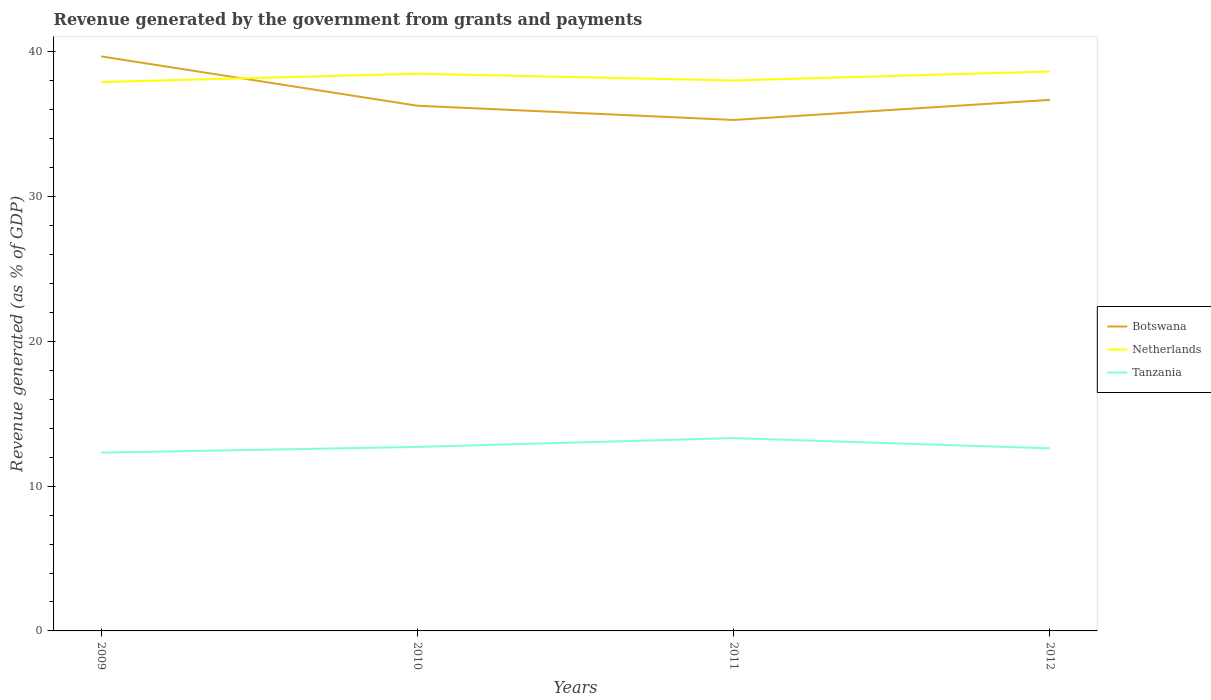Across all years, what is the maximum revenue generated by the government in Tanzania?
Your answer should be very brief. 12.31. What is the total revenue generated by the government in Tanzania in the graph?
Your answer should be compact. 0.71. What is the difference between the highest and the second highest revenue generated by the government in Botswana?
Provide a short and direct response. 4.39. What is the difference between the highest and the lowest revenue generated by the government in Botswana?
Provide a succinct answer. 1. Is the revenue generated by the government in Netherlands strictly greater than the revenue generated by the government in Tanzania over the years?
Offer a terse response. No. How many years are there in the graph?
Provide a succinct answer. 4. What is the difference between two consecutive major ticks on the Y-axis?
Provide a short and direct response. 10. Are the values on the major ticks of Y-axis written in scientific E-notation?
Offer a terse response. No. Does the graph contain any zero values?
Make the answer very short. No. How many legend labels are there?
Your answer should be very brief. 3. What is the title of the graph?
Keep it short and to the point. Revenue generated by the government from grants and payments. What is the label or title of the Y-axis?
Offer a terse response. Revenue generated (as % of GDP). What is the Revenue generated (as % of GDP) of Botswana in 2009?
Your answer should be very brief. 39.68. What is the Revenue generated (as % of GDP) in Netherlands in 2009?
Make the answer very short. 37.91. What is the Revenue generated (as % of GDP) of Tanzania in 2009?
Provide a short and direct response. 12.31. What is the Revenue generated (as % of GDP) in Botswana in 2010?
Your answer should be very brief. 36.27. What is the Revenue generated (as % of GDP) of Netherlands in 2010?
Give a very brief answer. 38.48. What is the Revenue generated (as % of GDP) of Tanzania in 2010?
Offer a very short reply. 12.71. What is the Revenue generated (as % of GDP) in Botswana in 2011?
Give a very brief answer. 35.29. What is the Revenue generated (as % of GDP) of Netherlands in 2011?
Your answer should be compact. 38.02. What is the Revenue generated (as % of GDP) in Tanzania in 2011?
Keep it short and to the point. 13.32. What is the Revenue generated (as % of GDP) of Botswana in 2012?
Your response must be concise. 36.68. What is the Revenue generated (as % of GDP) of Netherlands in 2012?
Your response must be concise. 38.64. What is the Revenue generated (as % of GDP) of Tanzania in 2012?
Offer a terse response. 12.61. Across all years, what is the maximum Revenue generated (as % of GDP) of Botswana?
Provide a succinct answer. 39.68. Across all years, what is the maximum Revenue generated (as % of GDP) of Netherlands?
Your answer should be very brief. 38.64. Across all years, what is the maximum Revenue generated (as % of GDP) of Tanzania?
Your answer should be compact. 13.32. Across all years, what is the minimum Revenue generated (as % of GDP) in Botswana?
Provide a succinct answer. 35.29. Across all years, what is the minimum Revenue generated (as % of GDP) of Netherlands?
Provide a succinct answer. 37.91. Across all years, what is the minimum Revenue generated (as % of GDP) in Tanzania?
Make the answer very short. 12.31. What is the total Revenue generated (as % of GDP) of Botswana in the graph?
Provide a succinct answer. 147.92. What is the total Revenue generated (as % of GDP) of Netherlands in the graph?
Your answer should be compact. 153.05. What is the total Revenue generated (as % of GDP) of Tanzania in the graph?
Your answer should be compact. 50.94. What is the difference between the Revenue generated (as % of GDP) in Botswana in 2009 and that in 2010?
Provide a succinct answer. 3.41. What is the difference between the Revenue generated (as % of GDP) of Netherlands in 2009 and that in 2010?
Your response must be concise. -0.58. What is the difference between the Revenue generated (as % of GDP) in Tanzania in 2009 and that in 2010?
Keep it short and to the point. -0.39. What is the difference between the Revenue generated (as % of GDP) in Botswana in 2009 and that in 2011?
Offer a very short reply. 4.39. What is the difference between the Revenue generated (as % of GDP) of Netherlands in 2009 and that in 2011?
Your answer should be compact. -0.11. What is the difference between the Revenue generated (as % of GDP) in Tanzania in 2009 and that in 2011?
Offer a terse response. -1. What is the difference between the Revenue generated (as % of GDP) of Botswana in 2009 and that in 2012?
Keep it short and to the point. 3. What is the difference between the Revenue generated (as % of GDP) of Netherlands in 2009 and that in 2012?
Your answer should be very brief. -0.73. What is the difference between the Revenue generated (as % of GDP) of Tanzania in 2009 and that in 2012?
Your response must be concise. -0.3. What is the difference between the Revenue generated (as % of GDP) in Botswana in 2010 and that in 2011?
Offer a very short reply. 0.98. What is the difference between the Revenue generated (as % of GDP) in Netherlands in 2010 and that in 2011?
Keep it short and to the point. 0.47. What is the difference between the Revenue generated (as % of GDP) in Tanzania in 2010 and that in 2011?
Keep it short and to the point. -0.61. What is the difference between the Revenue generated (as % of GDP) in Botswana in 2010 and that in 2012?
Ensure brevity in your answer.  -0.41. What is the difference between the Revenue generated (as % of GDP) of Netherlands in 2010 and that in 2012?
Offer a terse response. -0.16. What is the difference between the Revenue generated (as % of GDP) of Tanzania in 2010 and that in 2012?
Offer a very short reply. 0.1. What is the difference between the Revenue generated (as % of GDP) in Botswana in 2011 and that in 2012?
Provide a short and direct response. -1.39. What is the difference between the Revenue generated (as % of GDP) in Netherlands in 2011 and that in 2012?
Keep it short and to the point. -0.62. What is the difference between the Revenue generated (as % of GDP) of Tanzania in 2011 and that in 2012?
Provide a short and direct response. 0.71. What is the difference between the Revenue generated (as % of GDP) of Botswana in 2009 and the Revenue generated (as % of GDP) of Netherlands in 2010?
Make the answer very short. 1.2. What is the difference between the Revenue generated (as % of GDP) in Botswana in 2009 and the Revenue generated (as % of GDP) in Tanzania in 2010?
Make the answer very short. 26.97. What is the difference between the Revenue generated (as % of GDP) of Netherlands in 2009 and the Revenue generated (as % of GDP) of Tanzania in 2010?
Keep it short and to the point. 25.2. What is the difference between the Revenue generated (as % of GDP) in Botswana in 2009 and the Revenue generated (as % of GDP) in Netherlands in 2011?
Provide a succinct answer. 1.66. What is the difference between the Revenue generated (as % of GDP) of Botswana in 2009 and the Revenue generated (as % of GDP) of Tanzania in 2011?
Ensure brevity in your answer.  26.36. What is the difference between the Revenue generated (as % of GDP) in Netherlands in 2009 and the Revenue generated (as % of GDP) in Tanzania in 2011?
Your response must be concise. 24.59. What is the difference between the Revenue generated (as % of GDP) in Botswana in 2009 and the Revenue generated (as % of GDP) in Netherlands in 2012?
Offer a very short reply. 1.04. What is the difference between the Revenue generated (as % of GDP) of Botswana in 2009 and the Revenue generated (as % of GDP) of Tanzania in 2012?
Your answer should be compact. 27.07. What is the difference between the Revenue generated (as % of GDP) of Netherlands in 2009 and the Revenue generated (as % of GDP) of Tanzania in 2012?
Offer a terse response. 25.3. What is the difference between the Revenue generated (as % of GDP) in Botswana in 2010 and the Revenue generated (as % of GDP) in Netherlands in 2011?
Your answer should be compact. -1.74. What is the difference between the Revenue generated (as % of GDP) in Botswana in 2010 and the Revenue generated (as % of GDP) in Tanzania in 2011?
Keep it short and to the point. 22.96. What is the difference between the Revenue generated (as % of GDP) in Netherlands in 2010 and the Revenue generated (as % of GDP) in Tanzania in 2011?
Your answer should be compact. 25.17. What is the difference between the Revenue generated (as % of GDP) of Botswana in 2010 and the Revenue generated (as % of GDP) of Netherlands in 2012?
Your answer should be very brief. -2.37. What is the difference between the Revenue generated (as % of GDP) in Botswana in 2010 and the Revenue generated (as % of GDP) in Tanzania in 2012?
Ensure brevity in your answer.  23.66. What is the difference between the Revenue generated (as % of GDP) of Netherlands in 2010 and the Revenue generated (as % of GDP) of Tanzania in 2012?
Keep it short and to the point. 25.88. What is the difference between the Revenue generated (as % of GDP) in Botswana in 2011 and the Revenue generated (as % of GDP) in Netherlands in 2012?
Offer a terse response. -3.35. What is the difference between the Revenue generated (as % of GDP) in Botswana in 2011 and the Revenue generated (as % of GDP) in Tanzania in 2012?
Your answer should be very brief. 22.68. What is the difference between the Revenue generated (as % of GDP) of Netherlands in 2011 and the Revenue generated (as % of GDP) of Tanzania in 2012?
Offer a very short reply. 25.41. What is the average Revenue generated (as % of GDP) in Botswana per year?
Give a very brief answer. 36.98. What is the average Revenue generated (as % of GDP) of Netherlands per year?
Ensure brevity in your answer.  38.26. What is the average Revenue generated (as % of GDP) in Tanzania per year?
Your response must be concise. 12.74. In the year 2009, what is the difference between the Revenue generated (as % of GDP) of Botswana and Revenue generated (as % of GDP) of Netherlands?
Give a very brief answer. 1.77. In the year 2009, what is the difference between the Revenue generated (as % of GDP) in Botswana and Revenue generated (as % of GDP) in Tanzania?
Make the answer very short. 27.37. In the year 2009, what is the difference between the Revenue generated (as % of GDP) of Netherlands and Revenue generated (as % of GDP) of Tanzania?
Your answer should be very brief. 25.6. In the year 2010, what is the difference between the Revenue generated (as % of GDP) of Botswana and Revenue generated (as % of GDP) of Netherlands?
Your answer should be very brief. -2.21. In the year 2010, what is the difference between the Revenue generated (as % of GDP) of Botswana and Revenue generated (as % of GDP) of Tanzania?
Offer a terse response. 23.57. In the year 2010, what is the difference between the Revenue generated (as % of GDP) in Netherlands and Revenue generated (as % of GDP) in Tanzania?
Your answer should be compact. 25.78. In the year 2011, what is the difference between the Revenue generated (as % of GDP) of Botswana and Revenue generated (as % of GDP) of Netherlands?
Your response must be concise. -2.73. In the year 2011, what is the difference between the Revenue generated (as % of GDP) in Botswana and Revenue generated (as % of GDP) in Tanzania?
Provide a succinct answer. 21.97. In the year 2011, what is the difference between the Revenue generated (as % of GDP) in Netherlands and Revenue generated (as % of GDP) in Tanzania?
Ensure brevity in your answer.  24.7. In the year 2012, what is the difference between the Revenue generated (as % of GDP) in Botswana and Revenue generated (as % of GDP) in Netherlands?
Your answer should be compact. -1.96. In the year 2012, what is the difference between the Revenue generated (as % of GDP) of Botswana and Revenue generated (as % of GDP) of Tanzania?
Your answer should be compact. 24.07. In the year 2012, what is the difference between the Revenue generated (as % of GDP) of Netherlands and Revenue generated (as % of GDP) of Tanzania?
Provide a succinct answer. 26.03. What is the ratio of the Revenue generated (as % of GDP) in Botswana in 2009 to that in 2010?
Your answer should be compact. 1.09. What is the ratio of the Revenue generated (as % of GDP) of Netherlands in 2009 to that in 2010?
Provide a short and direct response. 0.98. What is the ratio of the Revenue generated (as % of GDP) in Tanzania in 2009 to that in 2010?
Give a very brief answer. 0.97. What is the ratio of the Revenue generated (as % of GDP) of Botswana in 2009 to that in 2011?
Make the answer very short. 1.12. What is the ratio of the Revenue generated (as % of GDP) of Netherlands in 2009 to that in 2011?
Keep it short and to the point. 1. What is the ratio of the Revenue generated (as % of GDP) in Tanzania in 2009 to that in 2011?
Keep it short and to the point. 0.92. What is the ratio of the Revenue generated (as % of GDP) of Botswana in 2009 to that in 2012?
Make the answer very short. 1.08. What is the ratio of the Revenue generated (as % of GDP) of Netherlands in 2009 to that in 2012?
Offer a very short reply. 0.98. What is the ratio of the Revenue generated (as % of GDP) in Tanzania in 2009 to that in 2012?
Provide a succinct answer. 0.98. What is the ratio of the Revenue generated (as % of GDP) of Botswana in 2010 to that in 2011?
Your response must be concise. 1.03. What is the ratio of the Revenue generated (as % of GDP) in Netherlands in 2010 to that in 2011?
Offer a very short reply. 1.01. What is the ratio of the Revenue generated (as % of GDP) in Tanzania in 2010 to that in 2011?
Your answer should be compact. 0.95. What is the ratio of the Revenue generated (as % of GDP) in Botswana in 2010 to that in 2012?
Make the answer very short. 0.99. What is the ratio of the Revenue generated (as % of GDP) in Netherlands in 2010 to that in 2012?
Your answer should be very brief. 1. What is the ratio of the Revenue generated (as % of GDP) of Tanzania in 2010 to that in 2012?
Keep it short and to the point. 1.01. What is the ratio of the Revenue generated (as % of GDP) in Botswana in 2011 to that in 2012?
Ensure brevity in your answer.  0.96. What is the ratio of the Revenue generated (as % of GDP) of Netherlands in 2011 to that in 2012?
Ensure brevity in your answer.  0.98. What is the ratio of the Revenue generated (as % of GDP) of Tanzania in 2011 to that in 2012?
Your response must be concise. 1.06. What is the difference between the highest and the second highest Revenue generated (as % of GDP) of Botswana?
Your response must be concise. 3. What is the difference between the highest and the second highest Revenue generated (as % of GDP) of Netherlands?
Provide a short and direct response. 0.16. What is the difference between the highest and the second highest Revenue generated (as % of GDP) of Tanzania?
Give a very brief answer. 0.61. What is the difference between the highest and the lowest Revenue generated (as % of GDP) of Botswana?
Give a very brief answer. 4.39. What is the difference between the highest and the lowest Revenue generated (as % of GDP) in Netherlands?
Provide a succinct answer. 0.73. 